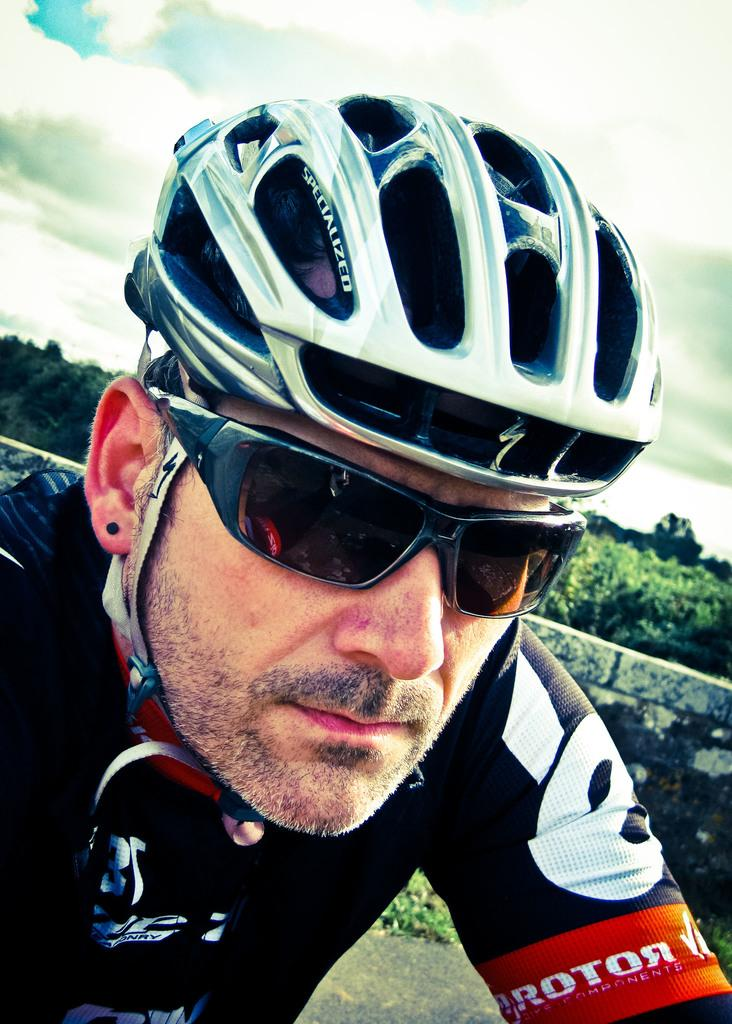What is the person at the bottom of the image wearing? The person is wearing a helmet and sunglasses. What can be seen in the background of the image? There are trees, plants, a wall, and clouds in the sky in the background of the image. What songs is the person singing while holding a hammer in the image? There is no person holding a hammer or singing songs in the image. 